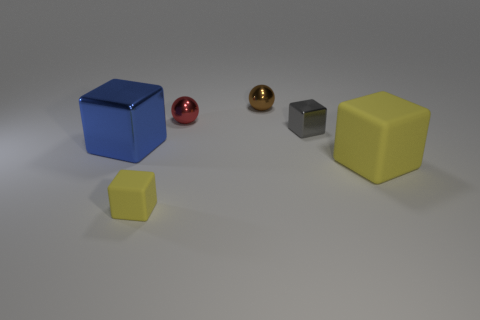Subtract all gray metallic cubes. How many cubes are left? 3 Add 1 small yellow things. How many objects exist? 7 Subtract all blue blocks. How many blocks are left? 3 Subtract 2 cubes. How many cubes are left? 2 Subtract all small cyan shiny blocks. Subtract all small red balls. How many objects are left? 5 Add 5 tiny shiny things. How many tiny shiny things are left? 8 Add 3 brown spheres. How many brown spheres exist? 4 Subtract 0 purple cylinders. How many objects are left? 6 Subtract all balls. How many objects are left? 4 Subtract all blue spheres. Subtract all yellow cylinders. How many spheres are left? 2 